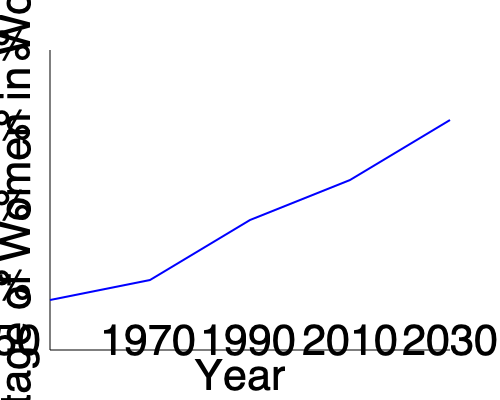Analyze the graph showing women's participation in the workforce from 1950 to 2030. Calculate the average rate of increase in women's workforce participation per decade, and discuss how this trend might impact traditional family structures. To answer this question, we need to follow these steps:

1. Determine the percentage of women in the workforce at the start and end points:
   - 1950: Approximately 30%
   - 2030: Approximately 75%

2. Calculate the total increase:
   $75\% - 30\% = 45\%$

3. Determine the number of decades between 1950 and 2030:
   $(2030 - 1950) / 10 = 8$ decades

4. Calculate the average rate of increase per decade:
   $45\% / 8 = 5.625\%$ per decade

5. Discuss the impact on traditional family structures:
   - The increasing participation of women in the workforce challenges the traditional notion of men being the sole breadwinners.
   - This trend may lead to a shift in household responsibilities, with men taking on more domestic duties.
   - It could result in delayed marriages and childbearing as women focus on careers.
   - The trend might necessitate changes in childcare arrangements and work-life balance policies.
   - Traditional gender roles within families may evolve, potentially leading to more egalitarian partnerships.
Answer: 5.625% increase per decade; challenges traditional family roles, potentially leading to more egalitarian partnerships and changes in household dynamics. 